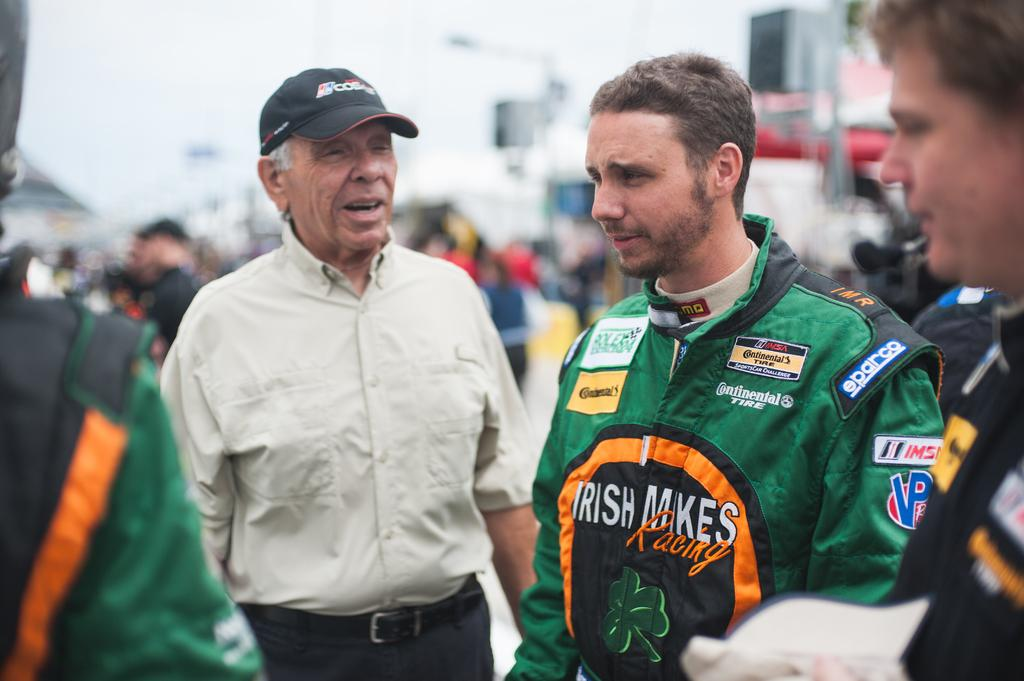What can be seen in the image? There are people standing in the image. What else is visible in the image besides the people? There are buildings visible in the image. Can you describe the clothing of one of the individuals in the image? A man is wearing a cap in the image. What books are the people reading in the image? There are no books visible in the image. What type of experience can be gained from the airport in the image? There is no airport present in the image. 